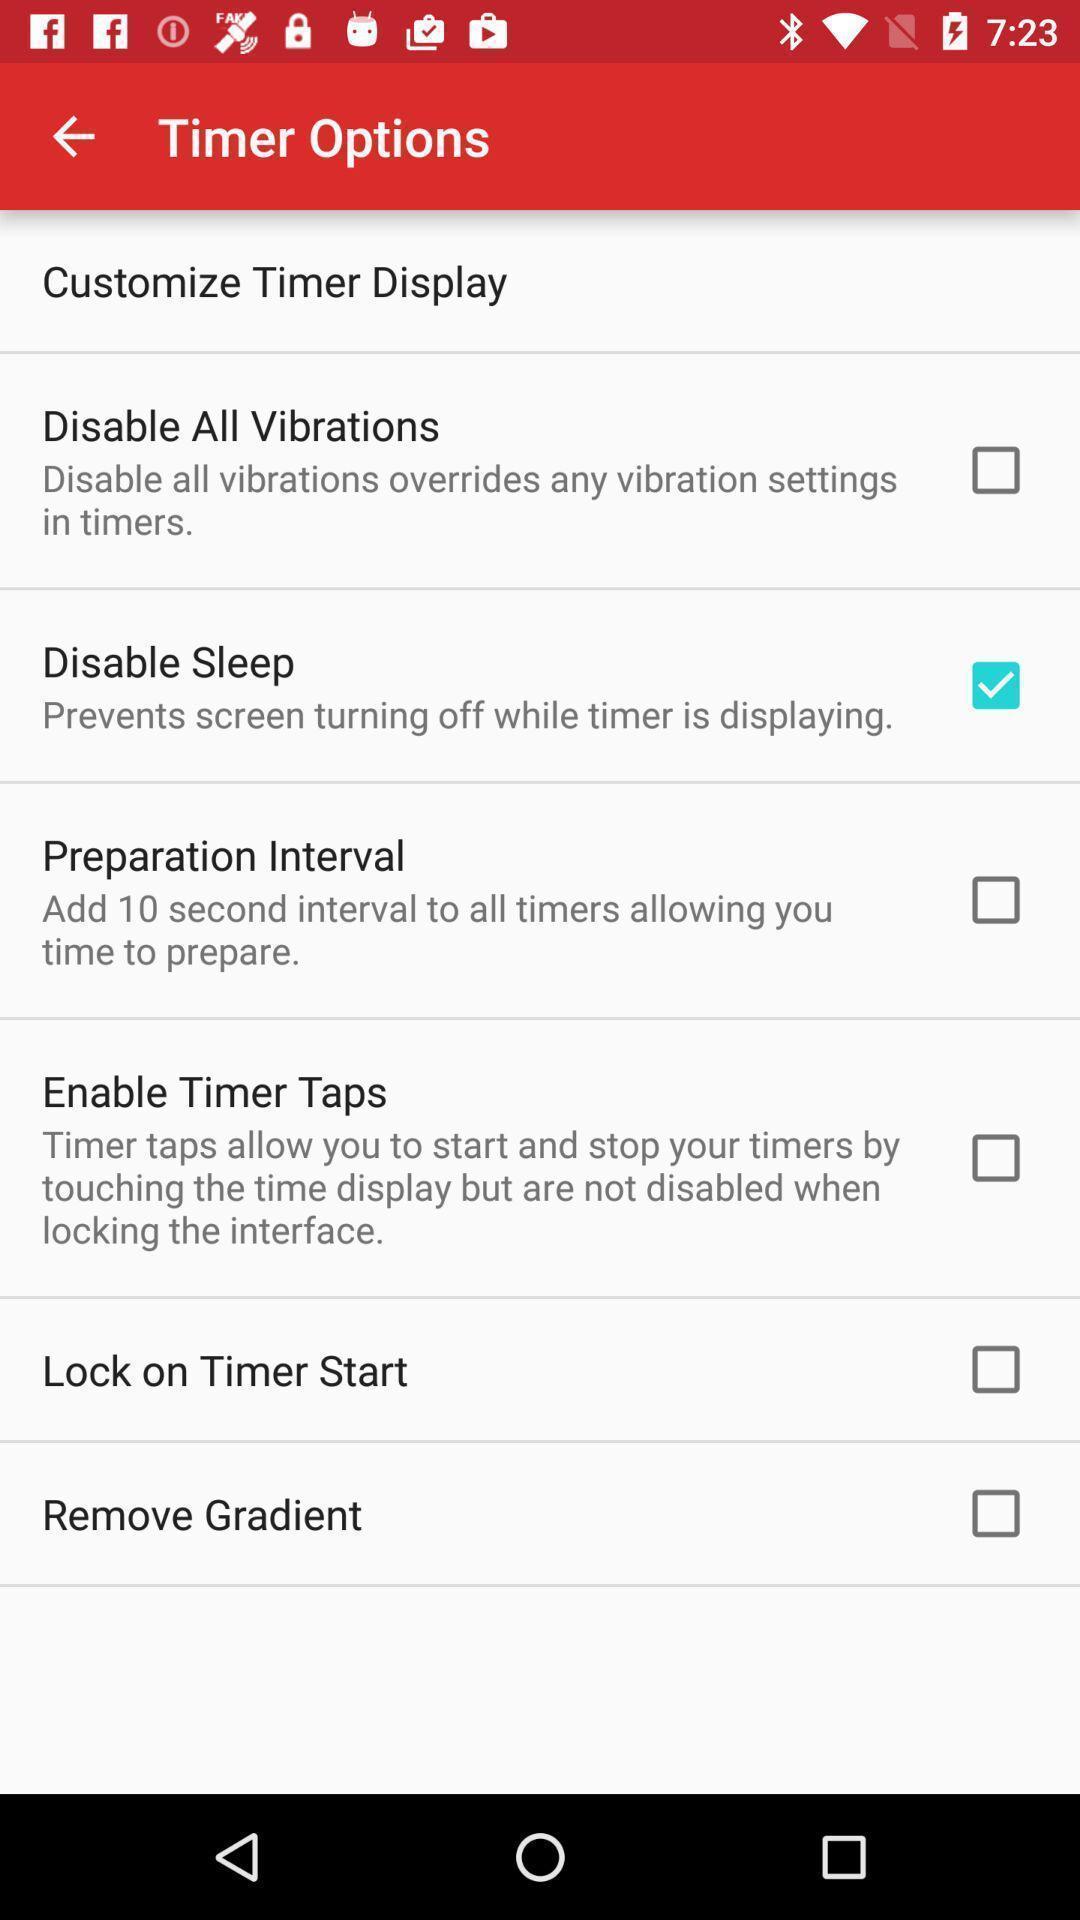Explain what's happening in this screen capture. Screen displaying multiple settings options. 